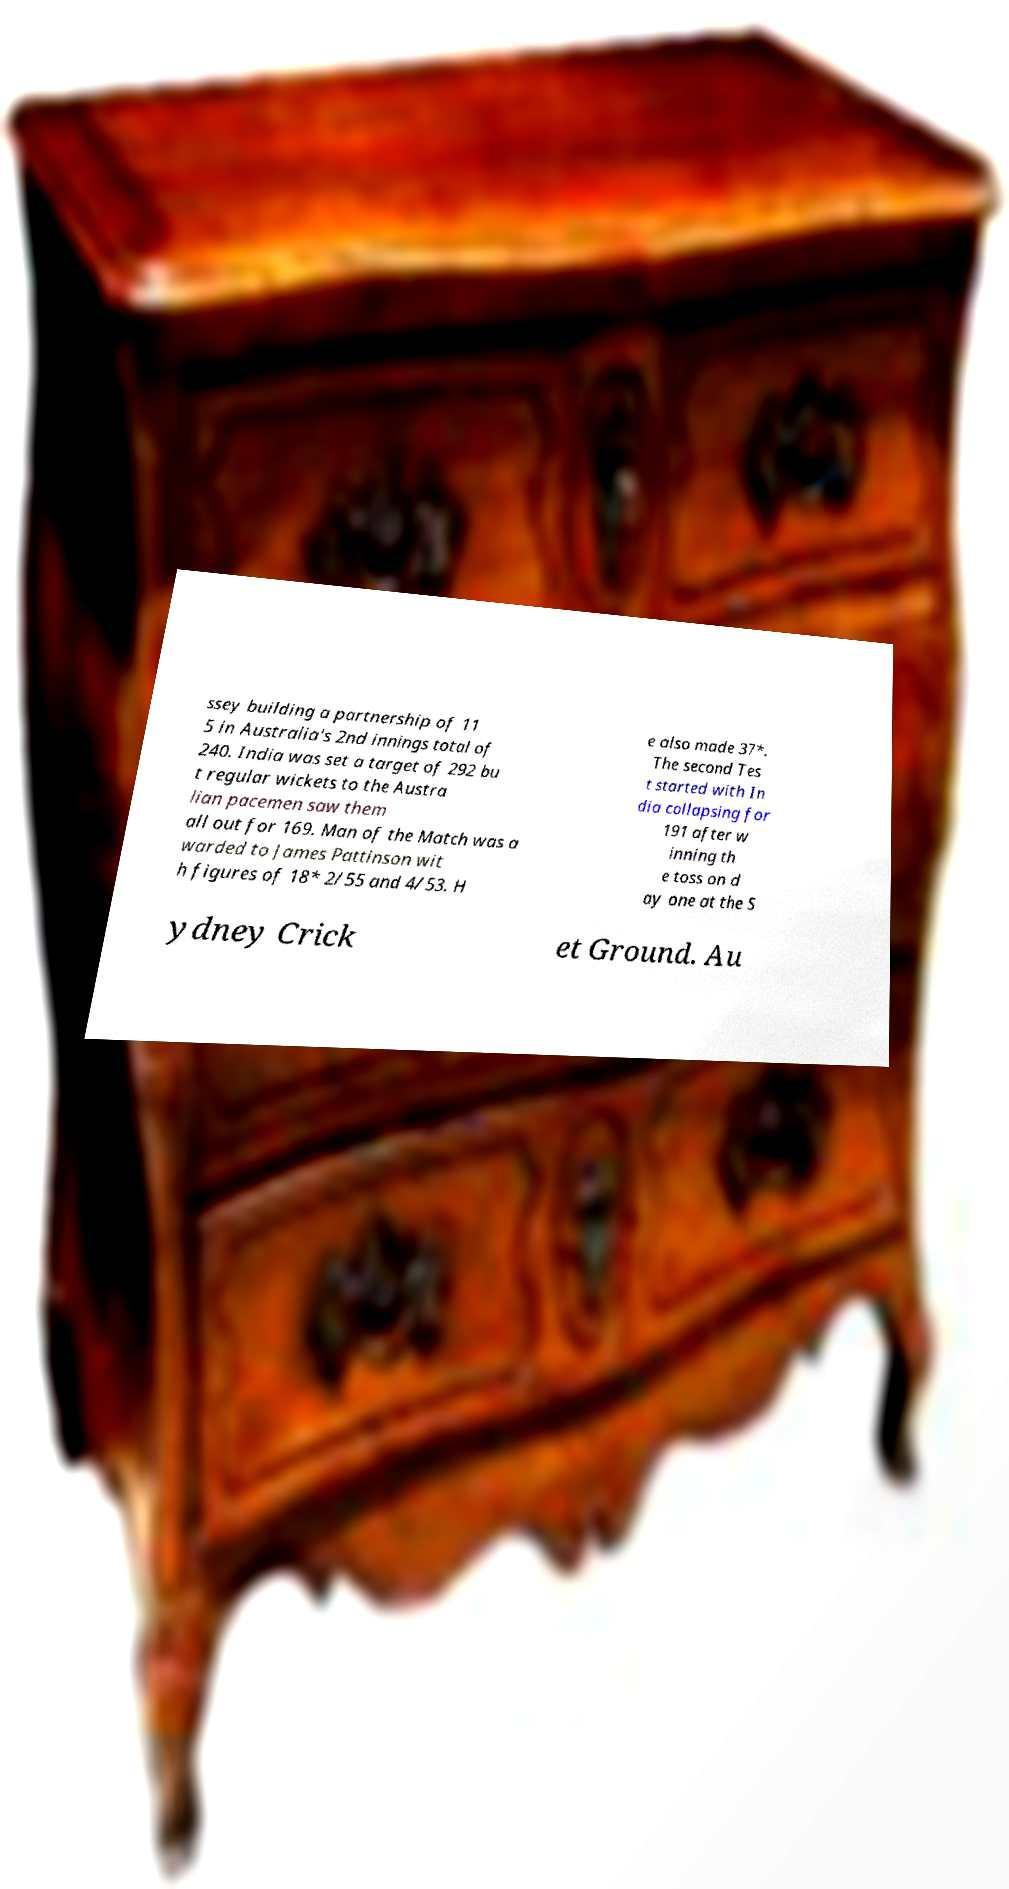Could you assist in decoding the text presented in this image and type it out clearly? ssey building a partnership of 11 5 in Australia's 2nd innings total of 240. India was set a target of 292 bu t regular wickets to the Austra lian pacemen saw them all out for 169. Man of the Match was a warded to James Pattinson wit h figures of 18* 2/55 and 4/53. H e also made 37*. The second Tes t started with In dia collapsing for 191 after w inning th e toss on d ay one at the S ydney Crick et Ground. Au 